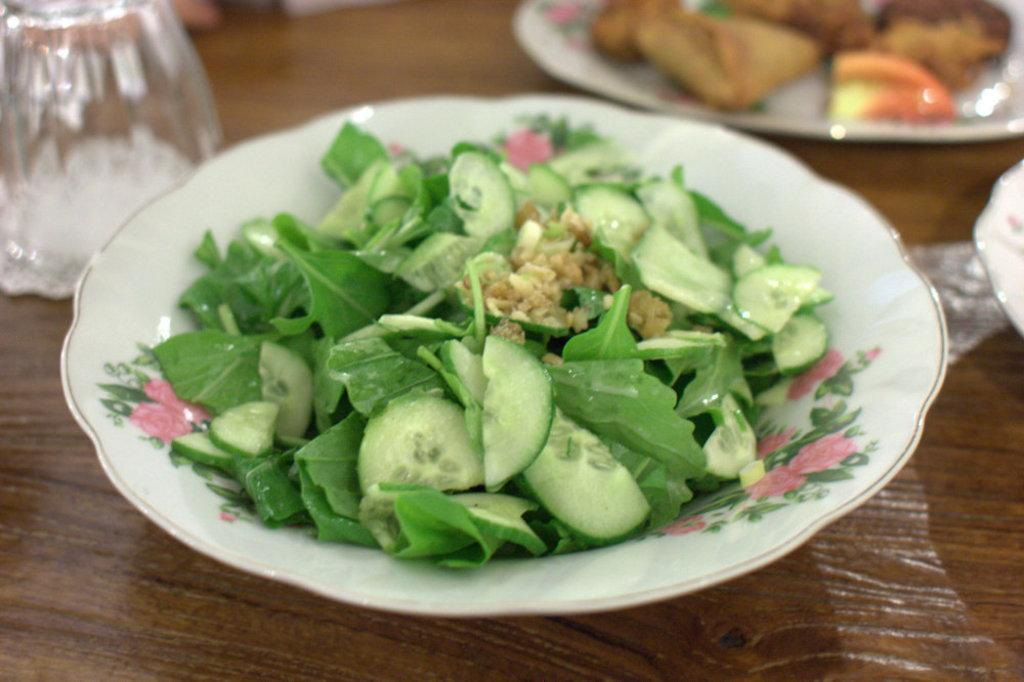What type of food is served on the plate in the image? There are vegetables served in a plate. Where is the plate located in the image? The plate is placed on a table. What else can be seen on the table in the image? There is a glass inverted on the table. What type of skirt is visible in the image? There is no skirt present in the image. What does the image smell like? The image does not have a smell, as it is a visual representation. 